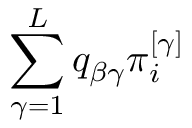Convert formula to latex. <formula><loc_0><loc_0><loc_500><loc_500>\sum _ { \gamma = 1 } ^ { L } q _ { \beta \gamma } \pi _ { i } ^ { \left [ \gamma \right ] }</formula> 